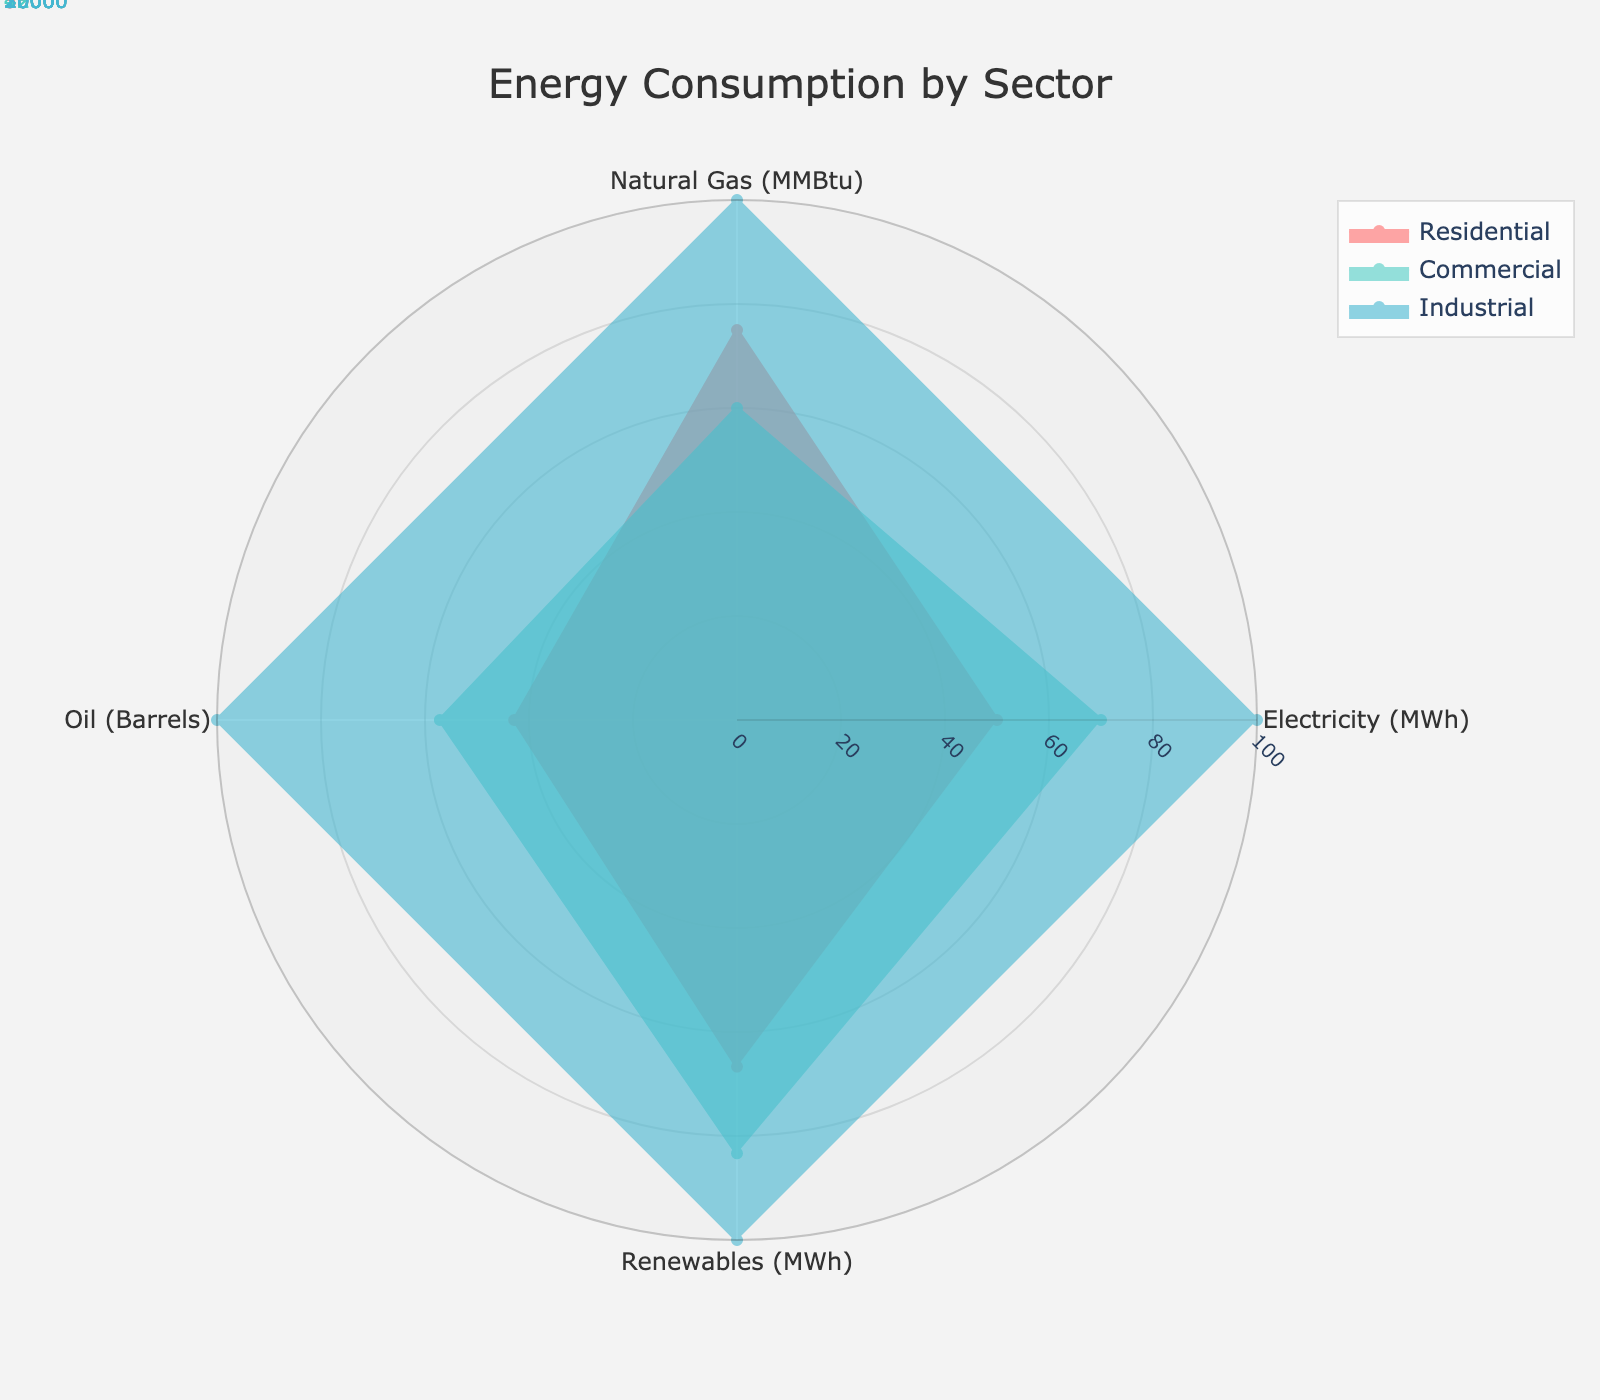What is the title of the radar chart? The title of the radar chart is given at the top of the figure; it summarizes what the chart represents.
Answer: Energy Consumption by Sector How many sectors are compared in this radar chart? Count the number of labeled areas under the legend section; each sector is represented by a different color.
Answer: 3 Which sector uses the most Electricity (MWh)? Identify the sector with the highest normalized value for Electricity (MWh) by looking at the plot's axis labeled "Electricity (MWh)."
Answer: Industrial What is the total consumption of Oil (Barrels) across all sectors? Sum the Oil consumption values for all sectors from the data provided in the chart annotations: 300 + 400 + 700.
Answer: 1400 Which sector has the smallest usage of Natural Gas (MMBtu)? Identify the sector with the lowest normalized value for Natural Gas (MMBtu) from the radar plot.
Answer: Commercial How does Residential sector's total Renewable (MWh) consumption compare with the average consumption across all sectors? First calculate the total Renewable consumption for Residential (2000) and then find the average consumption across sectors: (2000 + 2500 + 3000)/3 = 2500. Compare these values.
Answer: Below average What is the difference in Electricity (MWh) consumption between the Commercial and Industrial sectors? Subtract the Electricity consumption for the Commercial sector from the Industrial sector from the given values: 10000 - 7000.
Answer: 3000 Among the sectors, which one shows the maximum variance in usage across all energy types? Examine the range of values for each sector across the energy types and identify the one with the largest variety of values.
Answer: Industrial What is the normalized value of Renewable (MWh) usage for the Commercial sector? From the provided chart, read the normalized value on the axis corresponding to Renewable (MWh) for the Commercial sector.
Answer: 83.33 Which sector is closest to having equal usage values across all energy types? Compare the normalized values of each sector across all energy types and find the one with minimal difference between the highest and lowest values.
Answer: Residential 